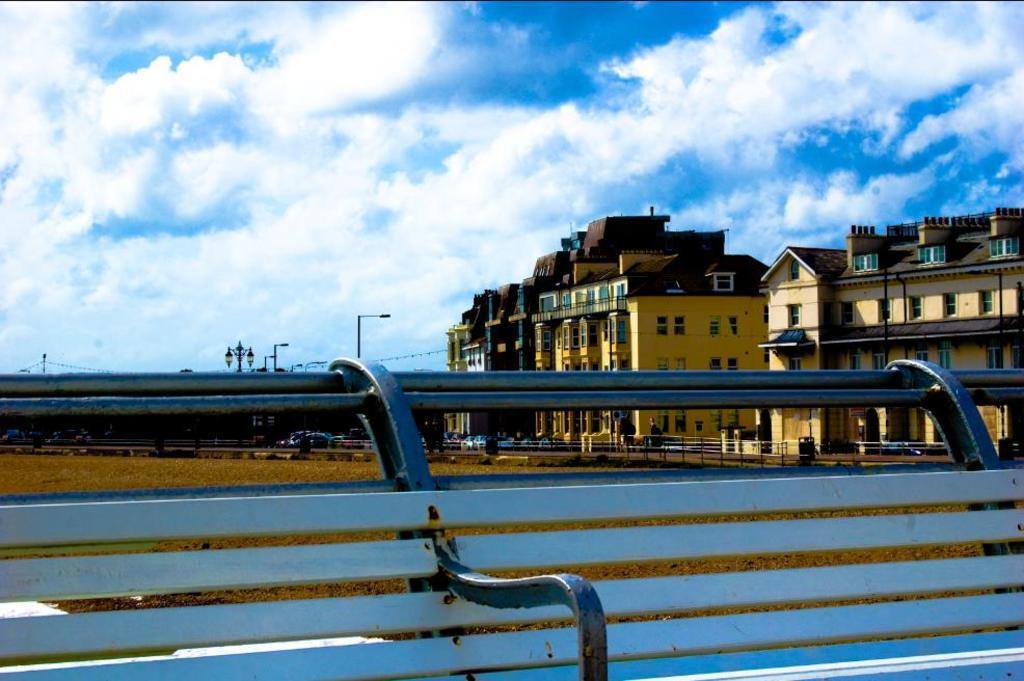What type of seating is visible in the image? There is a bench in the image. What structures can be seen in the image? There are buildings in the image. What else is present in the image besides the bench and buildings? Vehicles and street lights are visible in the image. What can be seen in the background of the image? The sky is visible in the background of the image. Can you tell me how many ears of corn are on the bench in the image? There are no ears of corn present on the bench or in the image. What type of animal is jumping on the trampoline in the image? There is no trampoline or animal present in the image. 